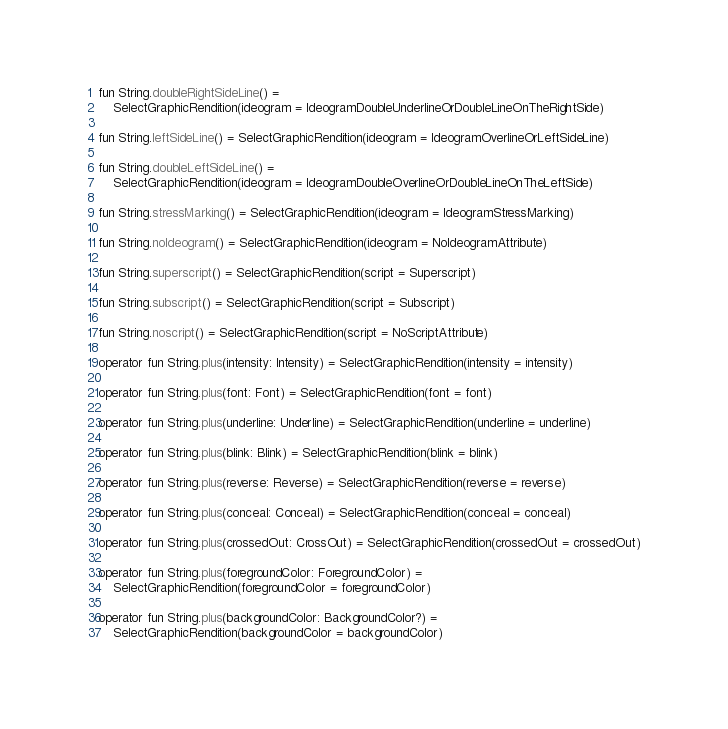<code> <loc_0><loc_0><loc_500><loc_500><_Kotlin_>fun String.doubleRightSideLine() =
    SelectGraphicRendition(ideogram = IdeogramDoubleUnderlineOrDoubleLineOnTheRightSide)

fun String.leftSideLine() = SelectGraphicRendition(ideogram = IdeogramOverlineOrLeftSideLine)

fun String.doubleLeftSideLine() =
    SelectGraphicRendition(ideogram = IdeogramDoubleOverlineOrDoubleLineOnTheLeftSide)

fun String.stressMarking() = SelectGraphicRendition(ideogram = IdeogramStressMarking)

fun String.noIdeogram() = SelectGraphicRendition(ideogram = NoIdeogramAttribute)

fun String.superscript() = SelectGraphicRendition(script = Superscript)

fun String.subscript() = SelectGraphicRendition(script = Subscript)

fun String.noscript() = SelectGraphicRendition(script = NoScriptAttribute)

operator fun String.plus(intensity: Intensity) = SelectGraphicRendition(intensity = intensity)

operator fun String.plus(font: Font) = SelectGraphicRendition(font = font)

operator fun String.plus(underline: Underline) = SelectGraphicRendition(underline = underline)

operator fun String.plus(blink: Blink) = SelectGraphicRendition(blink = blink)

operator fun String.plus(reverse: Reverse) = SelectGraphicRendition(reverse = reverse)

operator fun String.plus(conceal: Conceal) = SelectGraphicRendition(conceal = conceal)

operator fun String.plus(crossedOut: CrossOut) = SelectGraphicRendition(crossedOut = crossedOut)

operator fun String.plus(foregroundColor: ForegroundColor) =
    SelectGraphicRendition(foregroundColor = foregroundColor)

operator fun String.plus(backgroundColor: BackgroundColor?) =
    SelectGraphicRendition(backgroundColor = backgroundColor)</code> 